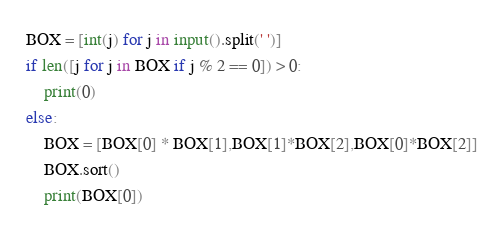<code> <loc_0><loc_0><loc_500><loc_500><_Python_>BOX = [int(j) for j in input().split(' ')]
if len([j for j in BOX if j % 2 == 0]) > 0:
    print(0)
else:
    BOX = [BOX[0] * BOX[1],BOX[1]*BOX[2],BOX[0]*BOX[2]]
    BOX.sort()
    print(BOX[0])
</code> 